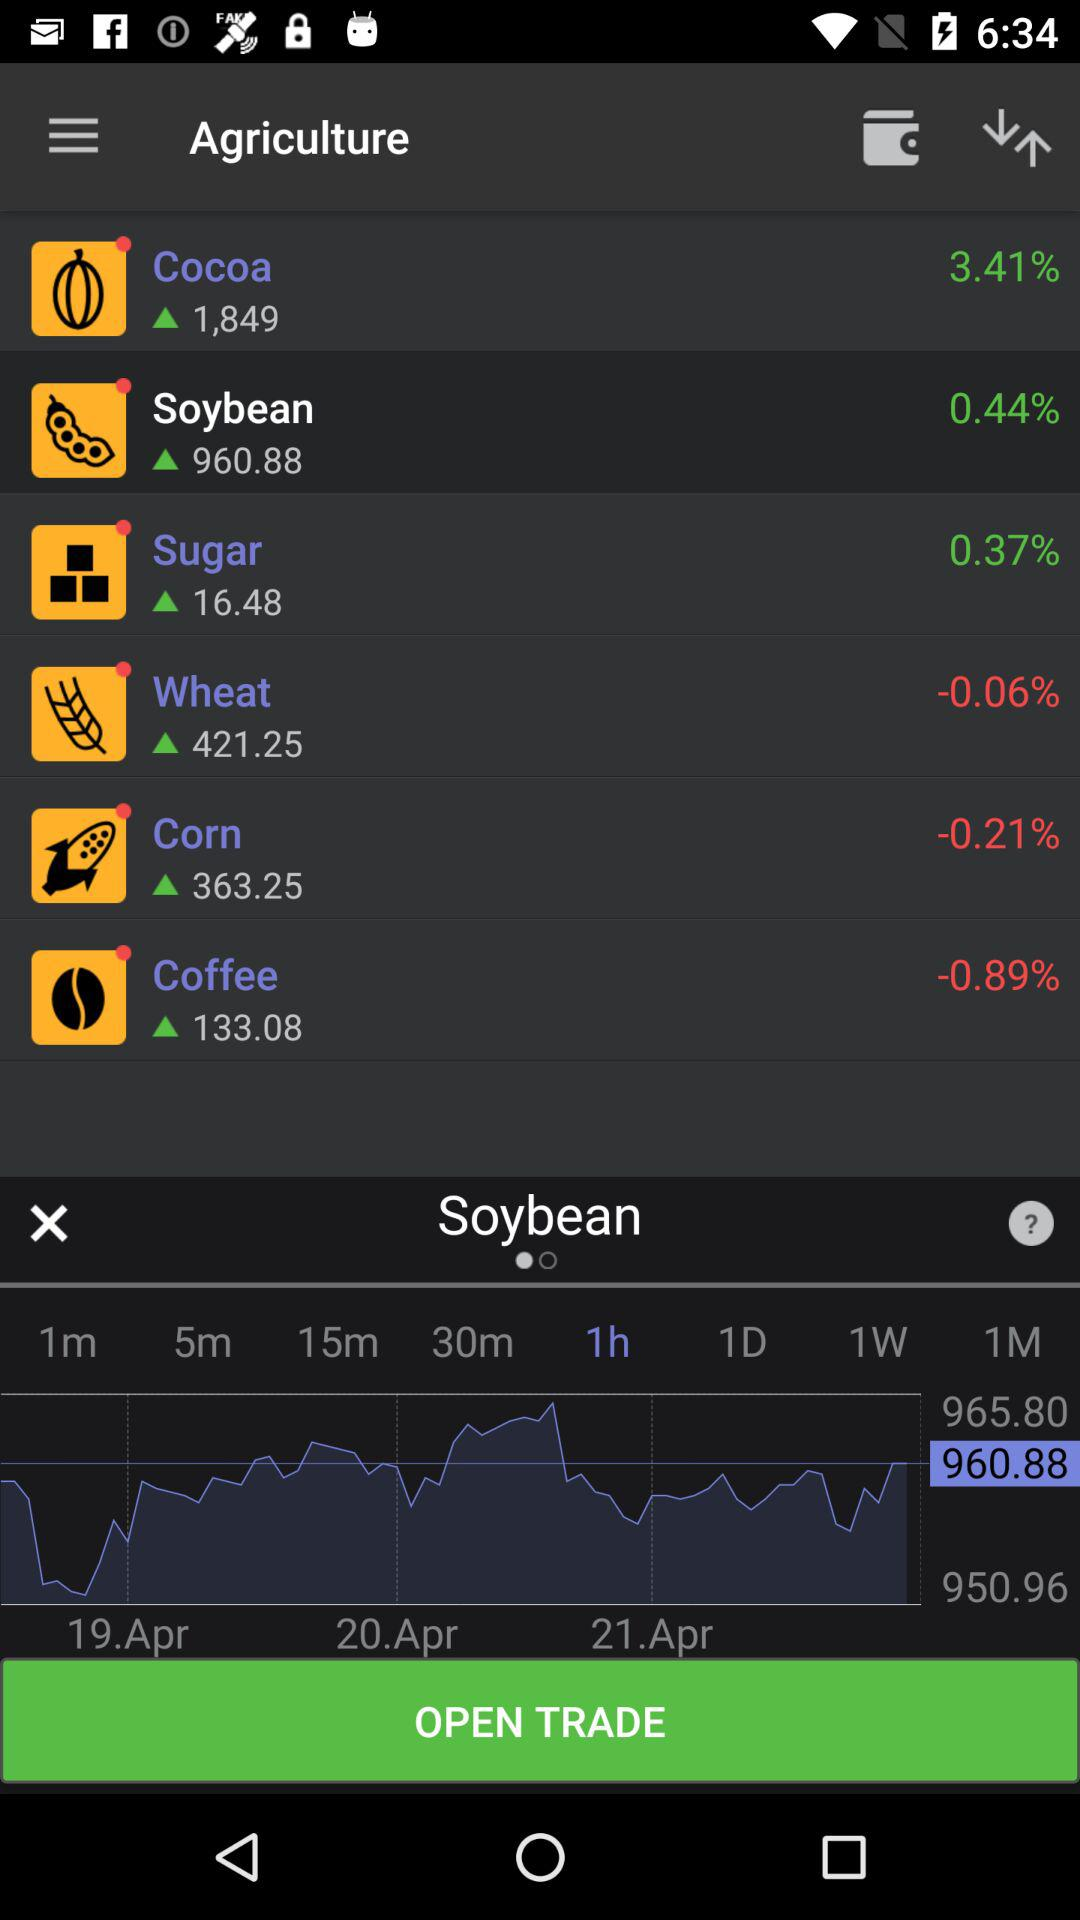Which dates' data is given on the screen? The given data is for April 19, April 20 and April 21. 